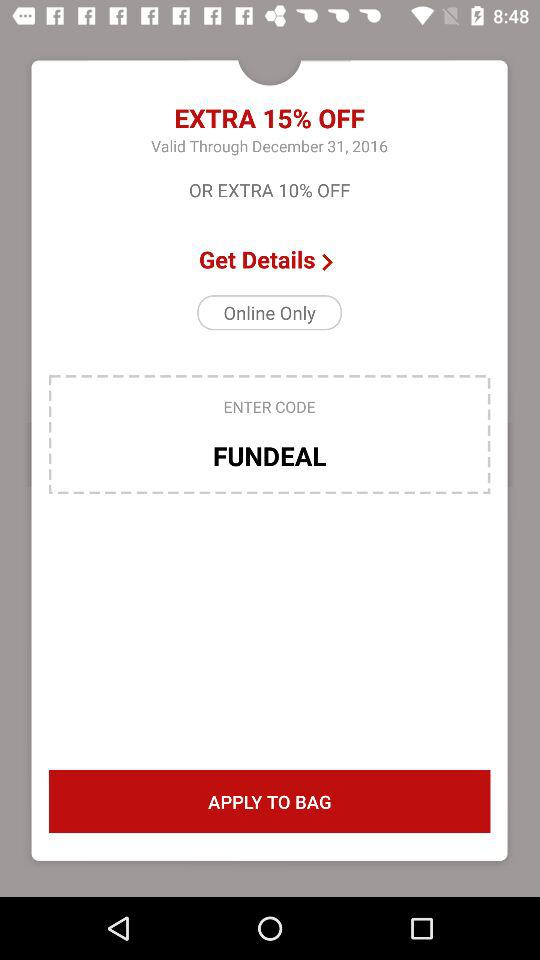What is the date? The date is December 31, 2016. 